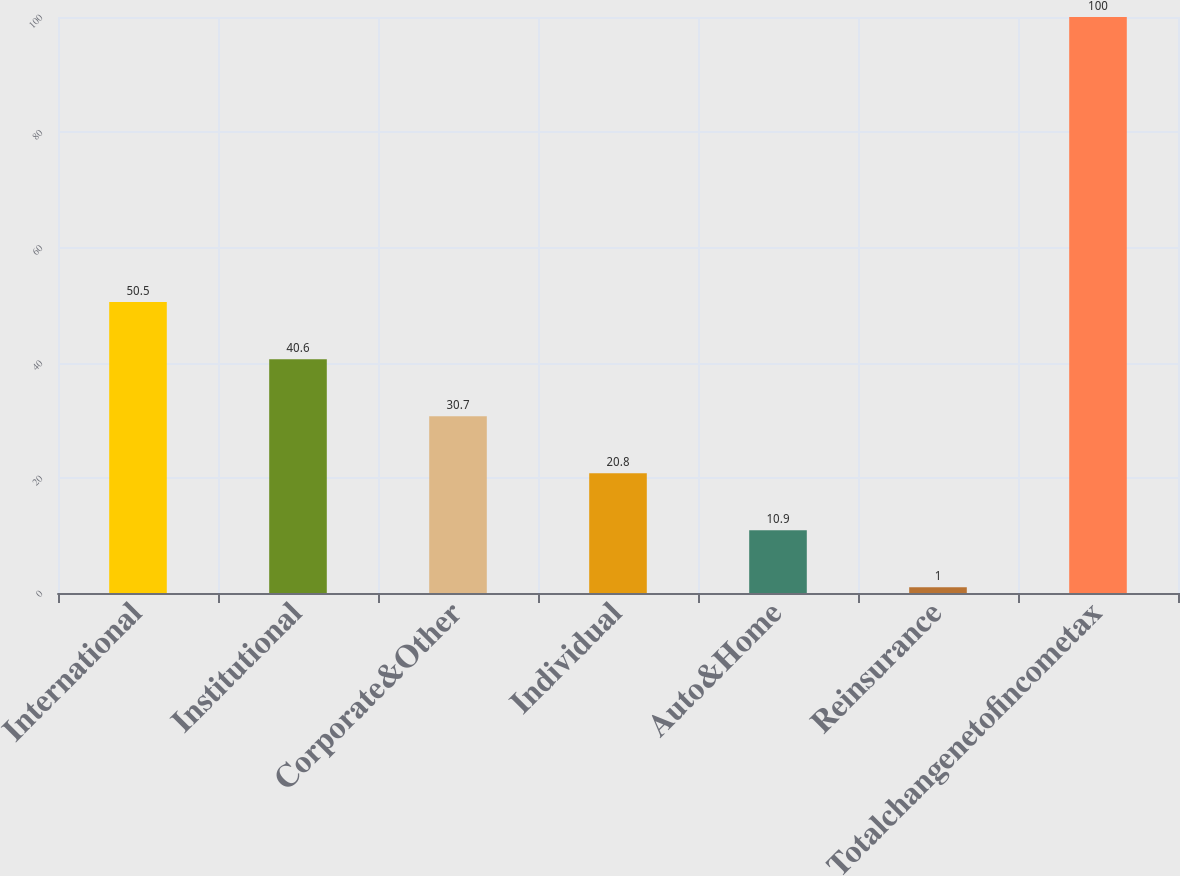<chart> <loc_0><loc_0><loc_500><loc_500><bar_chart><fcel>International<fcel>Institutional<fcel>Corporate&Other<fcel>Individual<fcel>Auto&Home<fcel>Reinsurance<fcel>Totalchangenetofincometax<nl><fcel>50.5<fcel>40.6<fcel>30.7<fcel>20.8<fcel>10.9<fcel>1<fcel>100<nl></chart> 